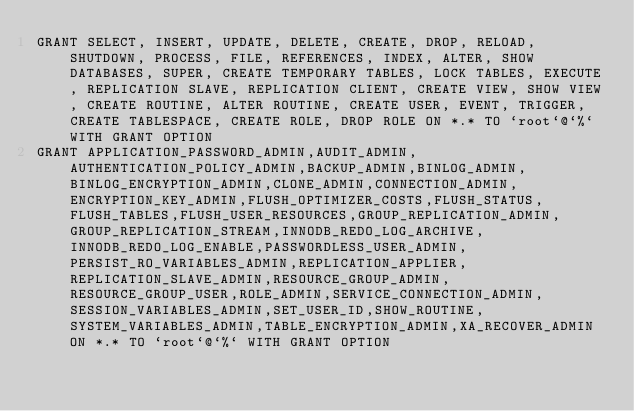<code> <loc_0><loc_0><loc_500><loc_500><_SQL_>GRANT SELECT, INSERT, UPDATE, DELETE, CREATE, DROP, RELOAD, SHUTDOWN, PROCESS, FILE, REFERENCES, INDEX, ALTER, SHOW DATABASES, SUPER, CREATE TEMPORARY TABLES, LOCK TABLES, EXECUTE, REPLICATION SLAVE, REPLICATION CLIENT, CREATE VIEW, SHOW VIEW, CREATE ROUTINE, ALTER ROUTINE, CREATE USER, EVENT, TRIGGER, CREATE TABLESPACE, CREATE ROLE, DROP ROLE ON *.* TO `root`@`%` WITH GRANT OPTION
GRANT APPLICATION_PASSWORD_ADMIN,AUDIT_ADMIN,AUTHENTICATION_POLICY_ADMIN,BACKUP_ADMIN,BINLOG_ADMIN,BINLOG_ENCRYPTION_ADMIN,CLONE_ADMIN,CONNECTION_ADMIN,ENCRYPTION_KEY_ADMIN,FLUSH_OPTIMIZER_COSTS,FLUSH_STATUS,FLUSH_TABLES,FLUSH_USER_RESOURCES,GROUP_REPLICATION_ADMIN,GROUP_REPLICATION_STREAM,INNODB_REDO_LOG_ARCHIVE,INNODB_REDO_LOG_ENABLE,PASSWORDLESS_USER_ADMIN,PERSIST_RO_VARIABLES_ADMIN,REPLICATION_APPLIER,REPLICATION_SLAVE_ADMIN,RESOURCE_GROUP_ADMIN,RESOURCE_GROUP_USER,ROLE_ADMIN,SERVICE_CONNECTION_ADMIN,SESSION_VARIABLES_ADMIN,SET_USER_ID,SHOW_ROUTINE,SYSTEM_VARIABLES_ADMIN,TABLE_ENCRYPTION_ADMIN,XA_RECOVER_ADMIN ON *.* TO `root`@`%` WITH GRANT OPTION
</code> 